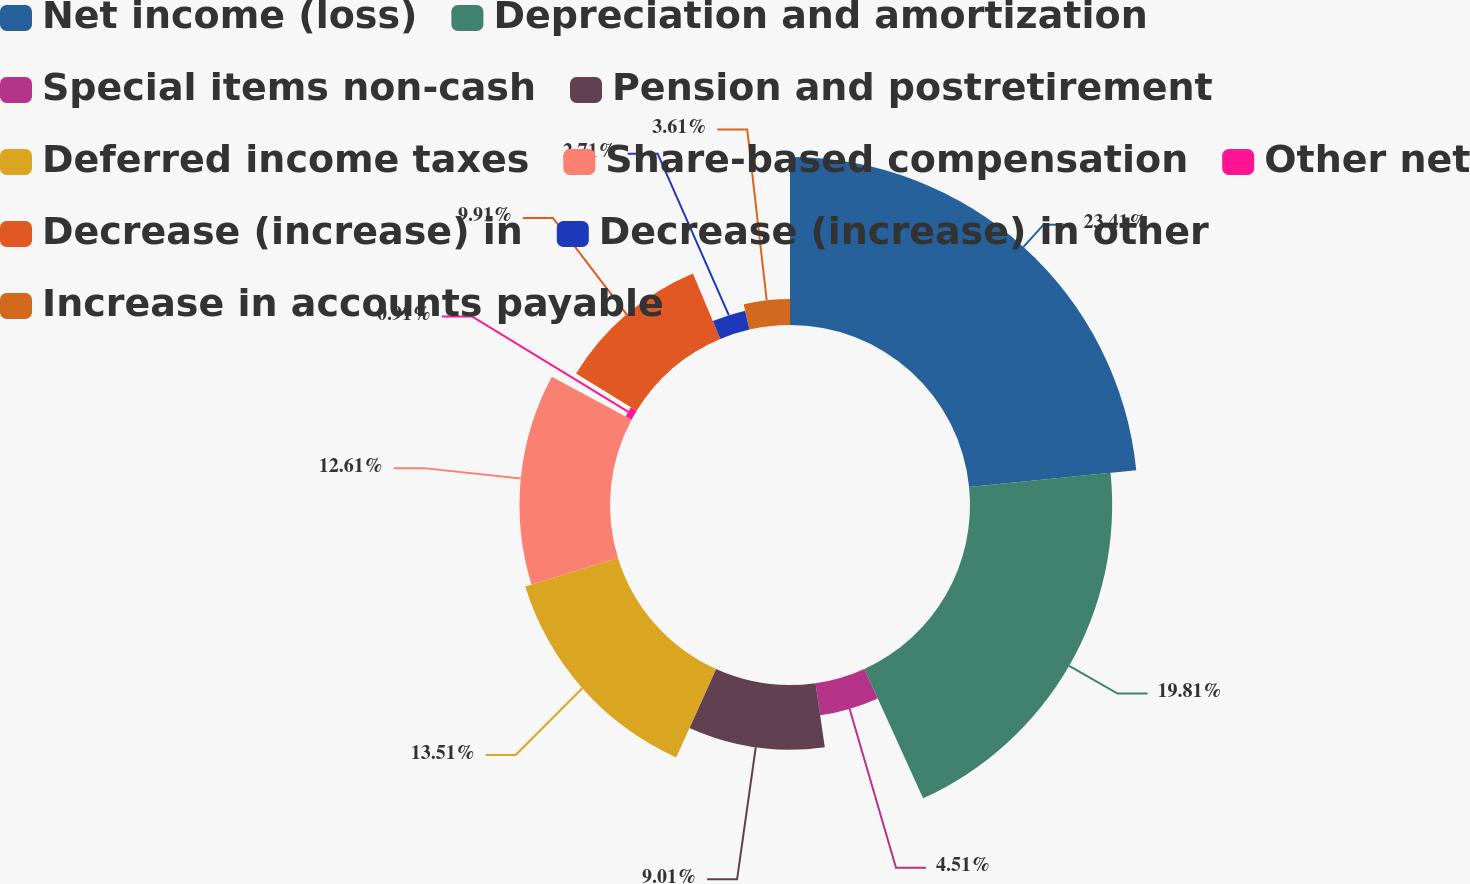Convert chart to OTSL. <chart><loc_0><loc_0><loc_500><loc_500><pie_chart><fcel>Net income (loss)<fcel>Depreciation and amortization<fcel>Special items non-cash<fcel>Pension and postretirement<fcel>Deferred income taxes<fcel>Share-based compensation<fcel>Other net<fcel>Decrease (increase) in<fcel>Decrease (increase) in other<fcel>Increase in accounts payable<nl><fcel>23.41%<fcel>19.81%<fcel>4.51%<fcel>9.01%<fcel>13.51%<fcel>12.61%<fcel>0.91%<fcel>9.91%<fcel>2.71%<fcel>3.61%<nl></chart> 